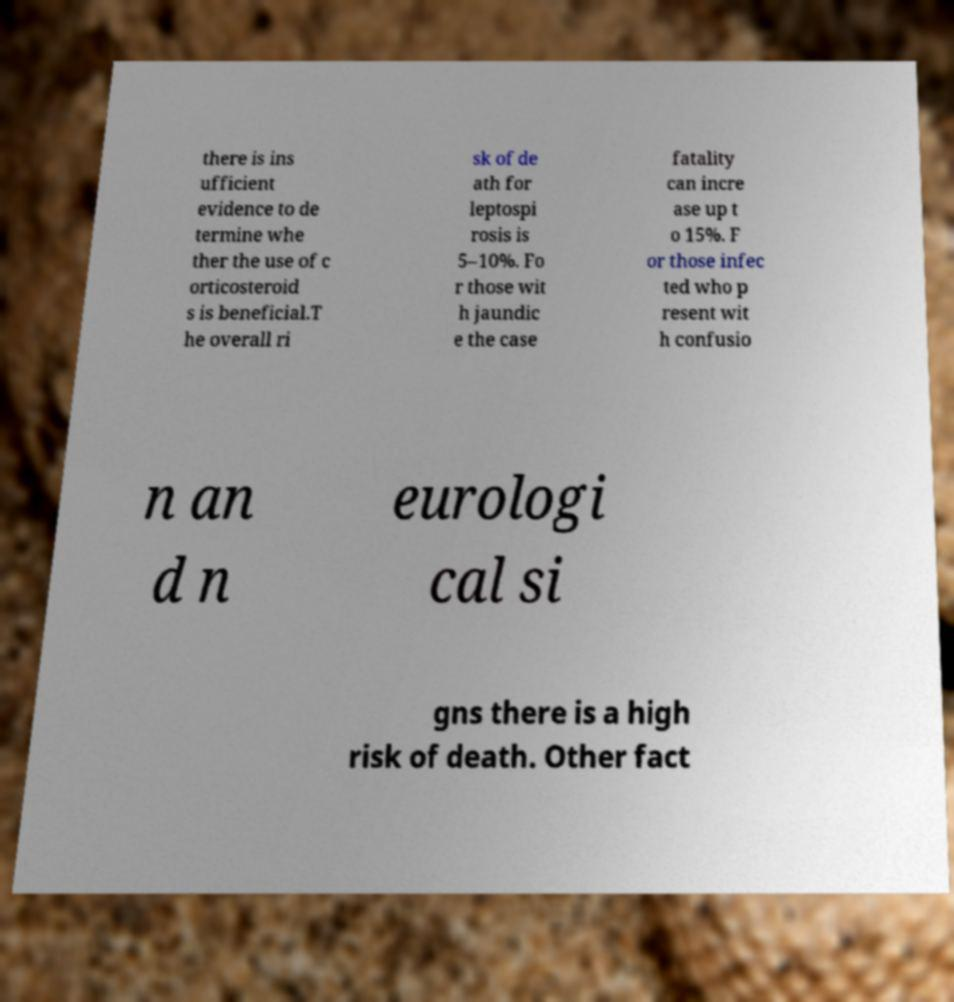Please read and relay the text visible in this image. What does it say? there is ins ufficient evidence to de termine whe ther the use of c orticosteroid s is beneficial.T he overall ri sk of de ath for leptospi rosis is 5–10%. Fo r those wit h jaundic e the case fatality can incre ase up t o 15%. F or those infec ted who p resent wit h confusio n an d n eurologi cal si gns there is a high risk of death. Other fact 